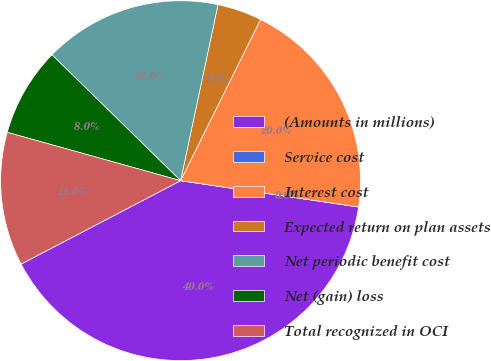<chart> <loc_0><loc_0><loc_500><loc_500><pie_chart><fcel>(Amounts in millions)<fcel>Service cost<fcel>Interest cost<fcel>Expected return on plan assets<fcel>Net periodic benefit cost<fcel>Net (gain) loss<fcel>Total recognized in OCI<nl><fcel>39.99%<fcel>0.0%<fcel>20.0%<fcel>4.0%<fcel>16.0%<fcel>8.0%<fcel>12.0%<nl></chart> 